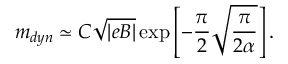<formula> <loc_0><loc_0><loc_500><loc_500>m _ { d y n } \simeq C \sqrt { | e B | } \exp \left [ - { \frac { \pi } { 2 } } \sqrt { \frac { \pi } { 2 \alpha } } \right ] .</formula> 